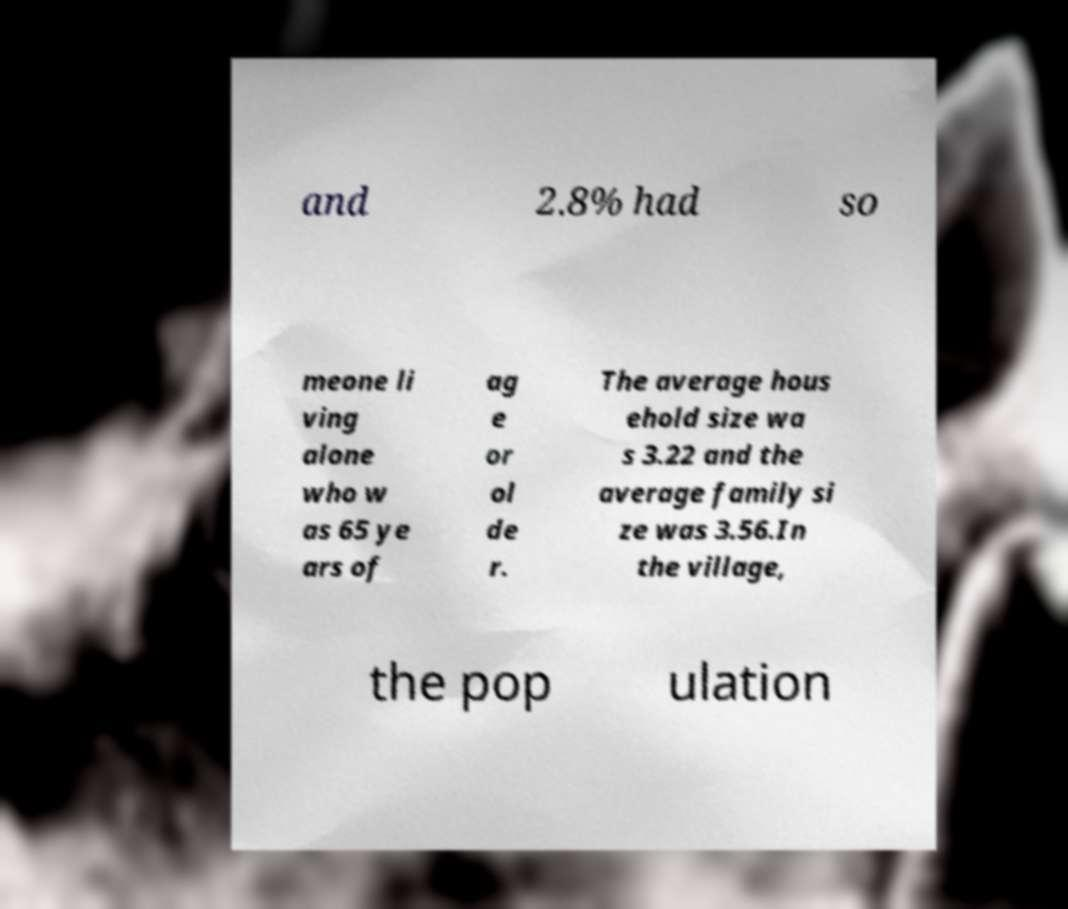Please identify and transcribe the text found in this image. and 2.8% had so meone li ving alone who w as 65 ye ars of ag e or ol de r. The average hous ehold size wa s 3.22 and the average family si ze was 3.56.In the village, the pop ulation 